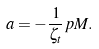Convert formula to latex. <formula><loc_0><loc_0><loc_500><loc_500>a = - \frac { 1 } { \zeta _ { t } } p M .</formula> 